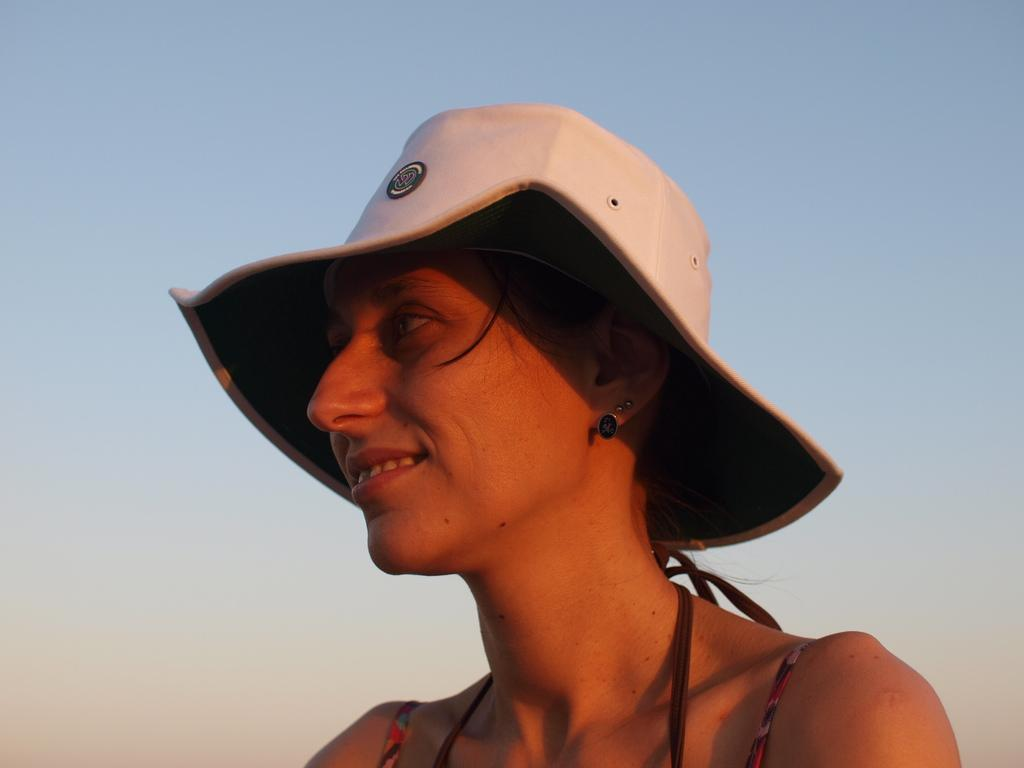Who is present in the image? There is a woman in the image. What is the woman wearing on her head? The woman is wearing a white hat. What is the woman's facial expression in the image? The woman is smiling. What can be seen in the background of the image? There is a sky visible in the background of the image. What type of feast is the woman attending in the image? There is no indication in the image that the woman is attending a feast, so it cannot be determined from the picture. 